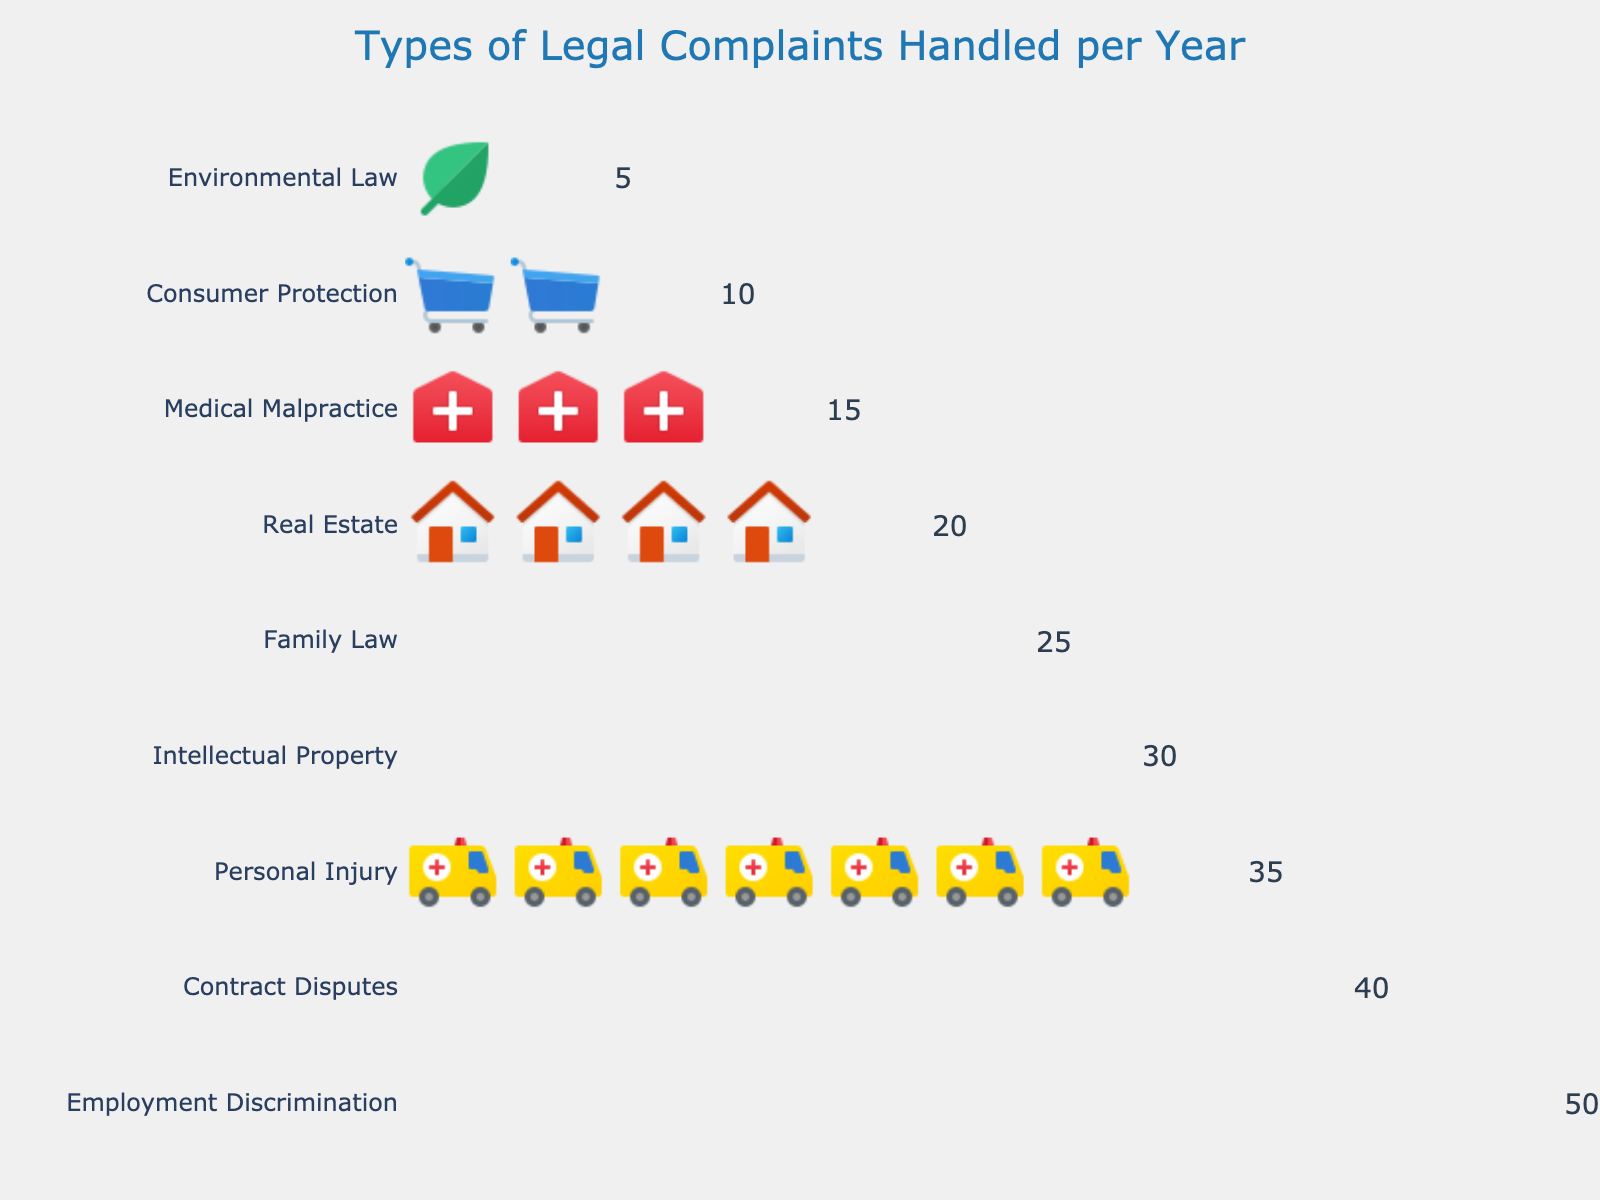How many types of legal complaints are illustrated in the plot? Count the number of rows or unique subject matters listed. The plot shows 9 different types of legal complaints.
Answer: 9 What is the title of the plot? Read the text located at the top-centre of the plot, which serves as the title. The title is "Types of Legal Complaints Handled per Year".
Answer: Types of Legal Complaints Handled per Year Which type of legal complaint has the highest number of icons? Find the row where the highest number of icons are displayed, representing the greatest count. Employment Discrimination has the highest number with 10 icons.
Answer: Employment Discrimination What is the combined total count of complaints for Contract Disputes and Personal Injury? Identify the counts for Contract Disputes (40) and Personal Injury (35), and sum them. 40 + 35 = 75.
Answer: 75 Which type of legal complaint has the lowest number of icons? Find the row with the least number of icons, which indicates the smallest count. Environmental Law has the lowest number with 1 icon.
Answer: Environmental Law How much greater is the count for Family Law complaints compared to Medical Malpractice complaints? Identify the counts for Family Law (25) and Medical Malpractice (15), and calculate the difference. 25 - 15 = 10.
Answer: 10 Which type of complaint has exactly 6 icons displayed? Locate the entry that corresponds to 6 icons, as determined by the count. Intellectual Property is represented by 6 icons.
Answer: Intellectual Property What is the average number of complaints for Real Estate, Medical Malpractice, and Consumer Protection? Sum the counts for Real Estate (20), Medical Malpractice (15), and Consumer Protection (10), then divide by 3. (20 + 15 + 10) / 3 = 15.
Answer: 15 How many complaint types have more than 30 icons? Identify and count the rows where the count exceeds 30. Employment Discrimination, Contract Disputes, and Personal Injury fall into this category. There are 3 such complaint types.
Answer: 3 